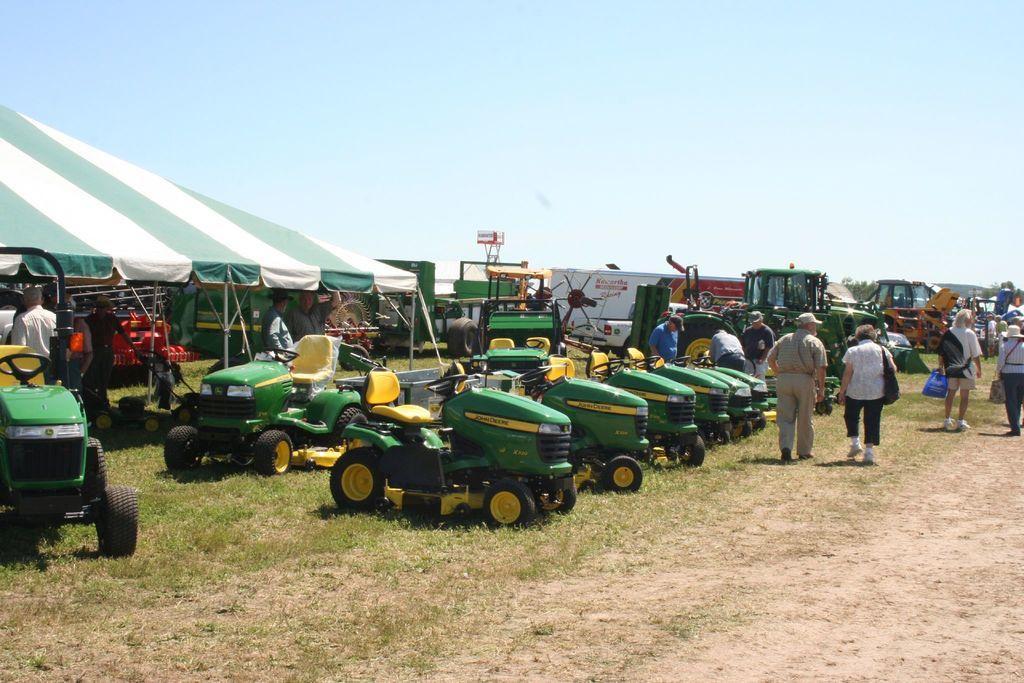In one or two sentences, can you explain what this image depicts? In this image in the center there are some vehicles and some persons are walking and also there are some tents. At the bottom there is grass and sand and at the top of the image there is sky, and in the center there are some poles. 